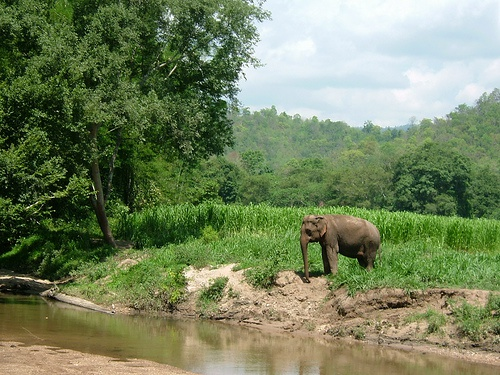Describe the objects in this image and their specific colors. I can see a elephant in darkgreen, black, gray, and tan tones in this image. 